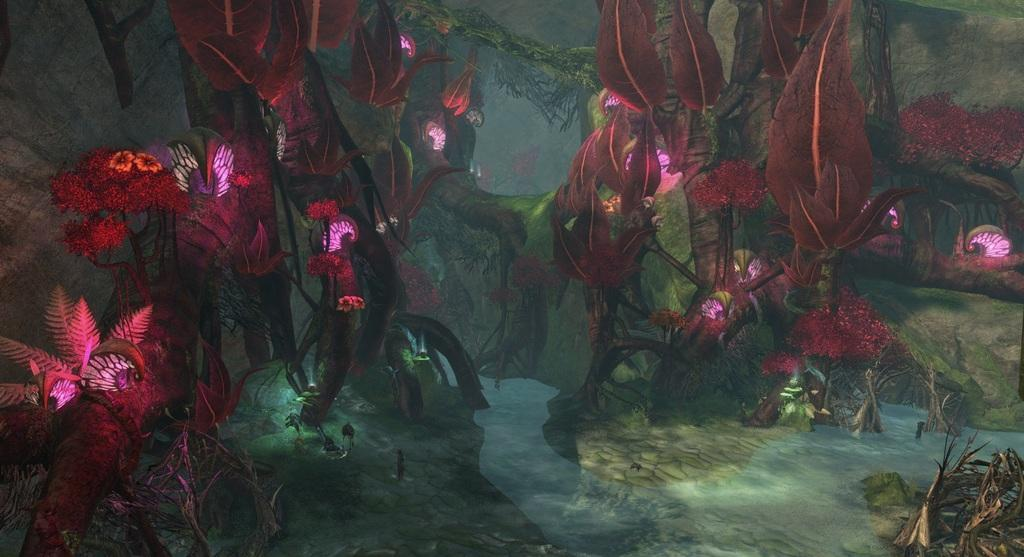What type of vegetation can be seen in the image? There are trees in the image. What natural element is visible in the image? There is water visible in the image. What type of quiver can be seen in the image? There is no quiver present in the image. What discovery was made in the image? The image does not depict a discovery; it simply shows trees and water. 